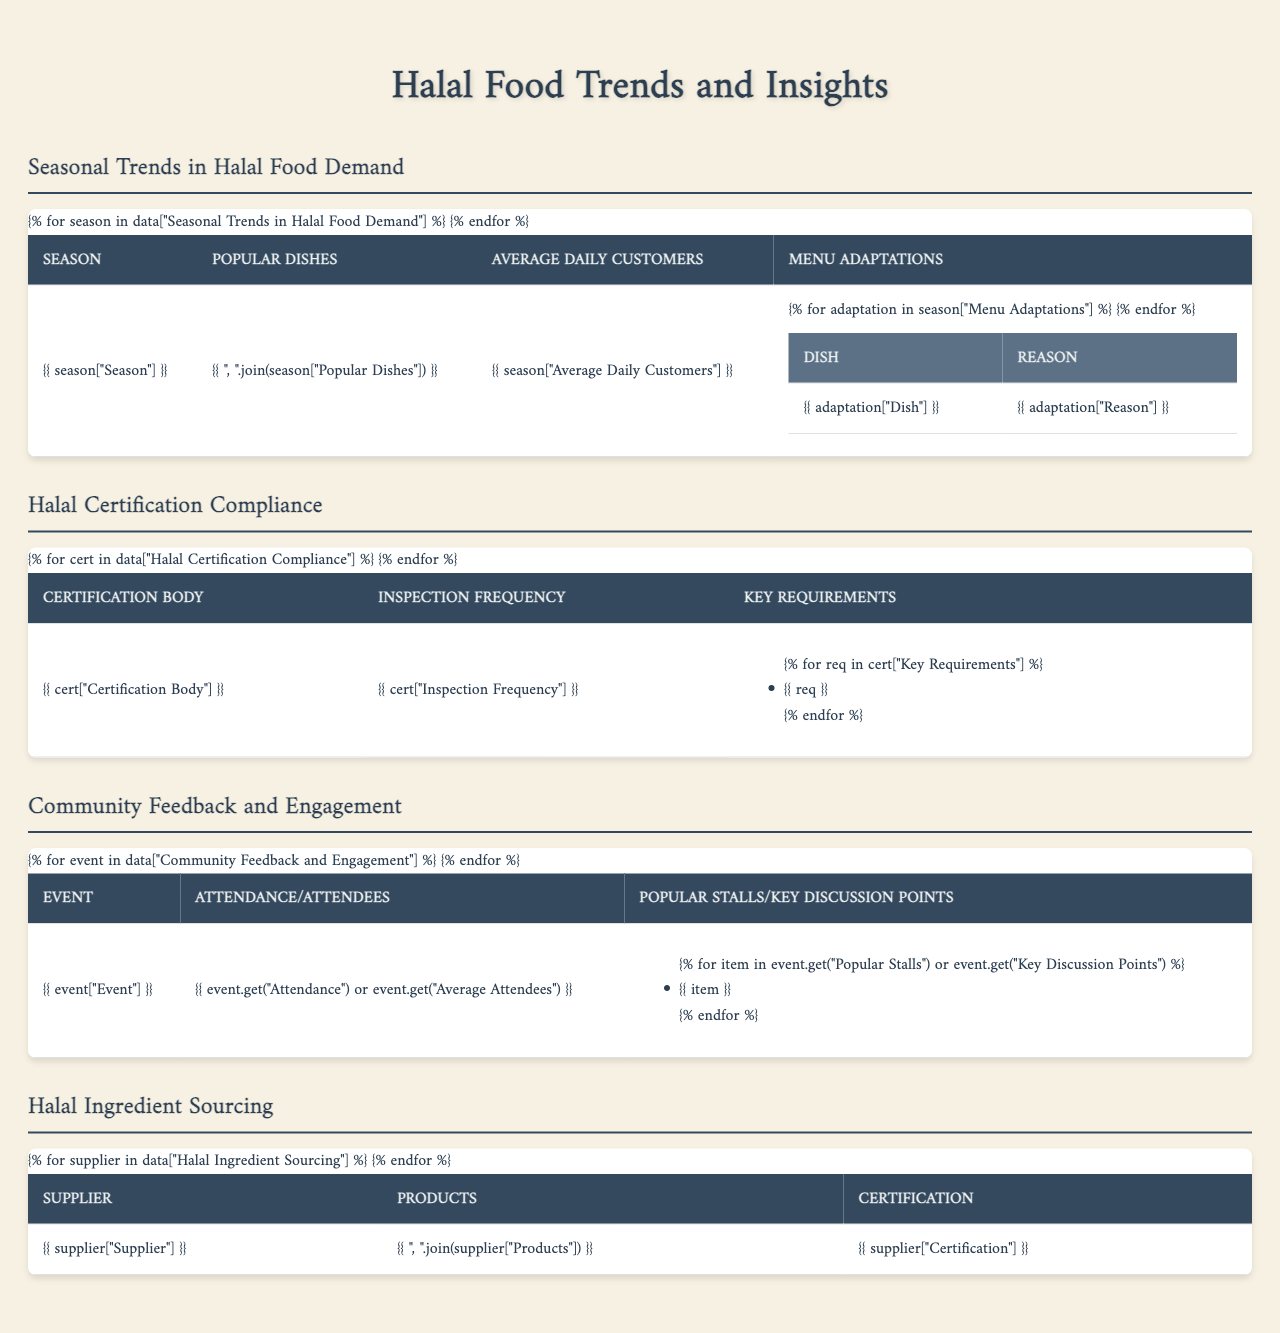What are the popular dishes in winter? The table lists the popular dishes under the "Winter" section, which includes "Lamb biryani," "Beef stew," "Lentil soup," and "Stuffed grape leaves."
Answer: Lamb biryani, Beef stew, Lentil soup, Stuffed grape leaves How many average daily customers were served during Ramadan? The average daily customers for the Ramadan season is stated in the table as 200.
Answer: 200 Which dish is adapted for summer as a refreshing drink? The table specifies that "Mango lassi" is added to the menu adaptations for summer as a refreshing drink option.
Answer: Mango lassi Is there a monthly inspection frequency for halal certification by the Halal Food Authority? According to the table, the inspection frequency for the Halal Food Authority (HFA) is quarterly, not monthly, so the answer is no.
Answer: No Which season has the highest average daily customers? The table shows the average daily customers for each season: Summer (150), Winter (120), and Ramadan (200). Ramadan has the highest number at 200.
Answer: Ramadan What is the purpose of a Suhoor meal box as per the adaptations listed for Ramadan? The table indicates that the "Suhoor meal boxes" are adapted for convenience, providing pre-dawn meals, specifically for Ramadan.
Answer: Convenient pre-dawn meals How many dishes are adapted in winter and what are they? The table displays two menu adaptations for winter: "Harira soup" for warmth and "Kunafa dessert" as a comforting treat.
Answer: 2 dishes: Harira soup, Kunafa dessert Which certification body conducts inspections more frequently, HFA or HMC? The table states that HMC conducts inspections monthly, while HFA does so quarterly. Therefore, HMC has a higher frequency.
Answer: HMC What total number of popular stalls is listed for the Annual Halal Food Festival? In the table, three popular stalls are mentioned: "Al-Medina Grill," "Saffron Spice Kitchen," and "Noor's Desserts," which totals to three.
Answer: 3 stalls Which dish in summer serves as a light option for hot weather? The table notes that the "Grilled vegetable platter" is included in the summer menu adaptations as a light option for hot weather.
Answer: Grilled vegetable platter How many total popular dishes are listed across all seasons? The total number of popular dishes is calculated by adding the number of dishes mentioned: 4 in Summer, 4 in Winter, and 4 in Ramadan, totaling 12 dishes.
Answer: 12 dishes What key requirement is mentioned for Halal certification by the Halal Monitoring Committee? The table lists "On-site Muslim inspector" under key requirements for Halal Monitoring Committee (HMC) certification.
Answer: On-site Muslim inspector Which supplier is verified by the local imam and what products do they provide? The table indicates that "Baraka Bakery" is verified by the local imam and provides "Pita bread, Lavash, Naan."
Answer: Baraka Bakery - Pita bread, Lavash, Naan Which community event has the highest attendance? The table indicates that the "Annual Halal Food Festival" has an attendance of 500, which is the highest compared to the monthly review meeting with 25 attendees.
Answer: Annual Halal Food Festival What adaptations are provided in the summer menu to appeal to customers? The summer menu adaptations include "Mango lassi" as a refreshing drink and a "Grilled vegetable platter" as a light option for hot weather, appealing to customers' needs in the heat.
Answer: Mango lassi, Grilled vegetable platter How often does the Halal Monitoring Committee conduct inspections? The table shows that the Halal Monitoring Committee conducts inspections monthly.
Answer: Monthly 